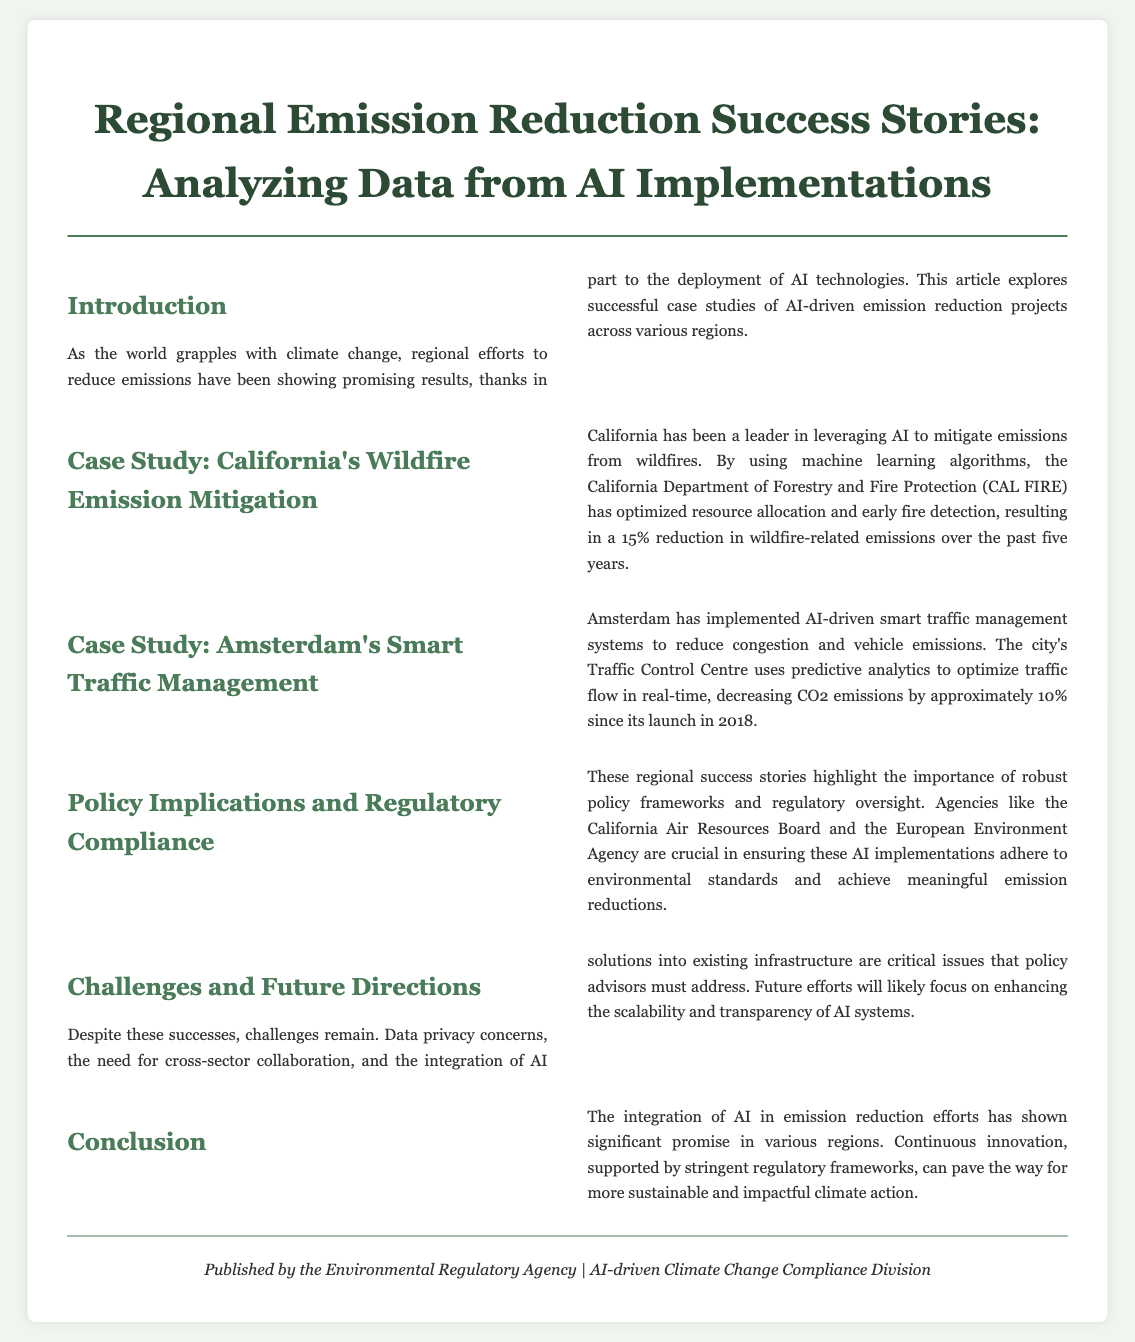What is the main focus of the article? The article explores successful case studies of AI-driven emission reduction projects across various regions.
Answer: AI-driven emission reduction projects What is the percentage reduction in wildfire-related emissions in California? California achieved a 15% reduction in wildfire-related emissions over the past five years through AI implementation.
Answer: 15% In which year did Amsterdam's smart traffic management system launch? The traffic management system in Amsterdam was launched in 2018.
Answer: 2018 Which agency is crucial for ensuring compliance in California? The California Air Resources Board is mentioned as a crucial agency for ensuring compliance with environmental standards.
Answer: California Air Resources Board What are some critical issues mentioned for future efforts in AI integration? The document mentions data privacy concerns, cross-sector collaboration, and infrastructure integration as critical issues.
Answer: Data privacy concerns, cross-sector collaboration, infrastructure integration What is the overall tone of the document regarding AI's role in emission reduction? The document has a positive tone regarding the integration of AI in emission reduction efforts.
Answer: Positive What is emphasized as essential for successful AI implementations? Robust policy frameworks and regulatory oversight are emphasized as essential for successful AI implementations.
Answer: Robust policy frameworks and regulatory oversight What region's case study focuses on wildfire emission mitigation? The case study focused on California in relation to wildfire emission mitigation.
Answer: California 